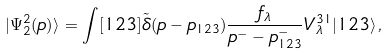<formula> <loc_0><loc_0><loc_500><loc_500>| \Psi _ { 2 } ^ { 2 } ( p ) \rangle = \int [ 1 2 3 ] \tilde { \delta } ( p - p _ { 1 2 3 } ) \frac { f _ { \lambda } } { p ^ { - } - p _ { 1 2 3 } ^ { - } } V _ { \lambda } ^ { 3 1 } | 1 2 3 \rangle \, ,</formula> 